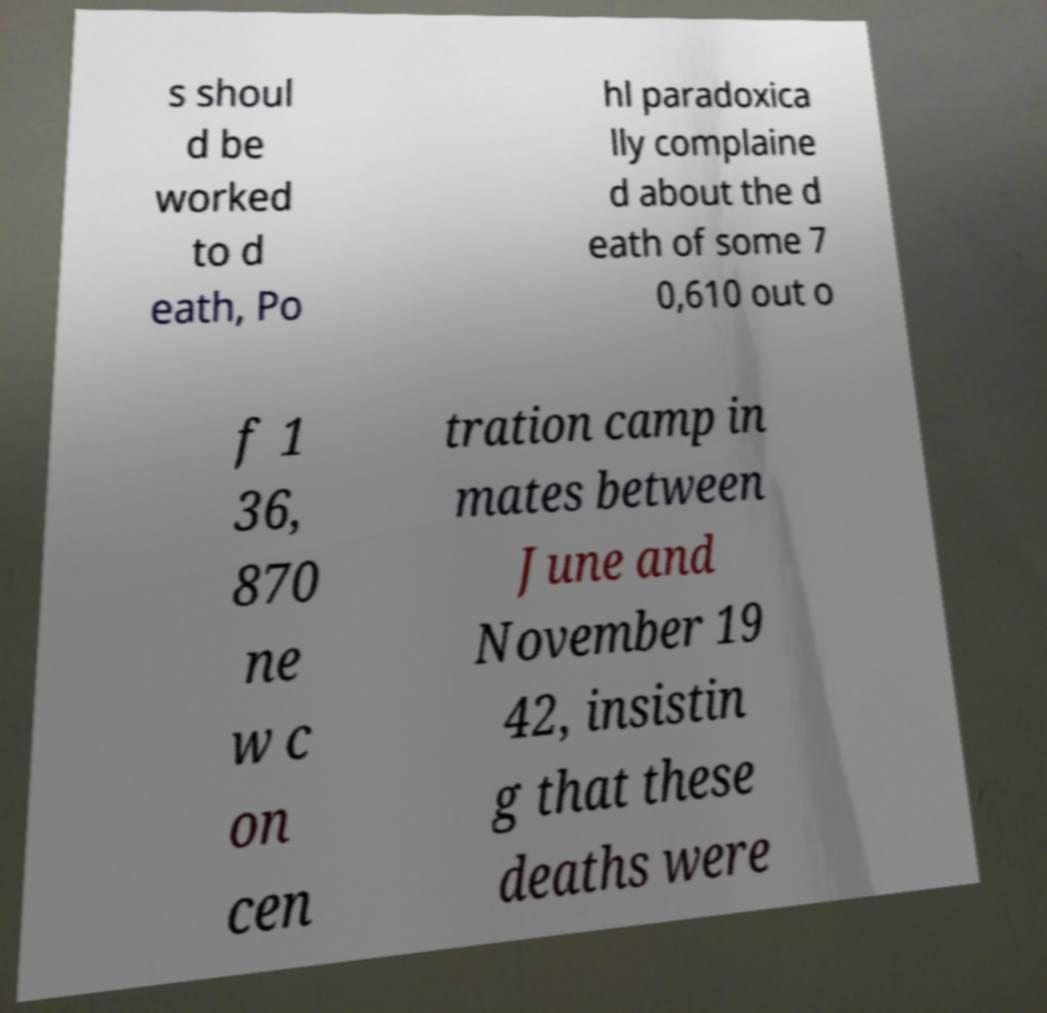Can you accurately transcribe the text from the provided image for me? s shoul d be worked to d eath, Po hl paradoxica lly complaine d about the d eath of some 7 0,610 out o f 1 36, 870 ne w c on cen tration camp in mates between June and November 19 42, insistin g that these deaths were 